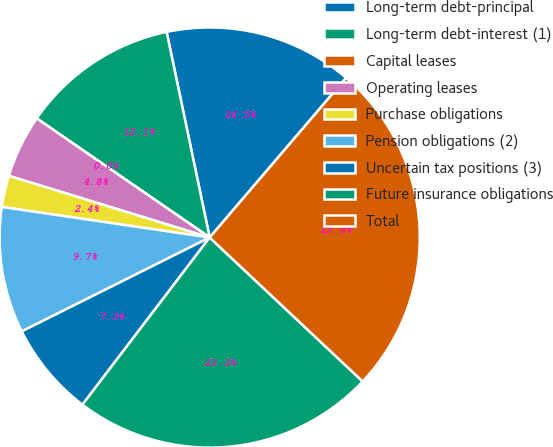Convert chart to OTSL. <chart><loc_0><loc_0><loc_500><loc_500><pie_chart><fcel>Long-term debt-principal<fcel>Long-term debt-interest (1)<fcel>Capital leases<fcel>Operating leases<fcel>Purchase obligations<fcel>Pension obligations (2)<fcel>Uncertain tax positions (3)<fcel>Future insurance obligations<fcel>Total<nl><fcel>14.54%<fcel>12.12%<fcel>0.0%<fcel>4.85%<fcel>2.42%<fcel>9.7%<fcel>7.27%<fcel>23.34%<fcel>25.76%<nl></chart> 